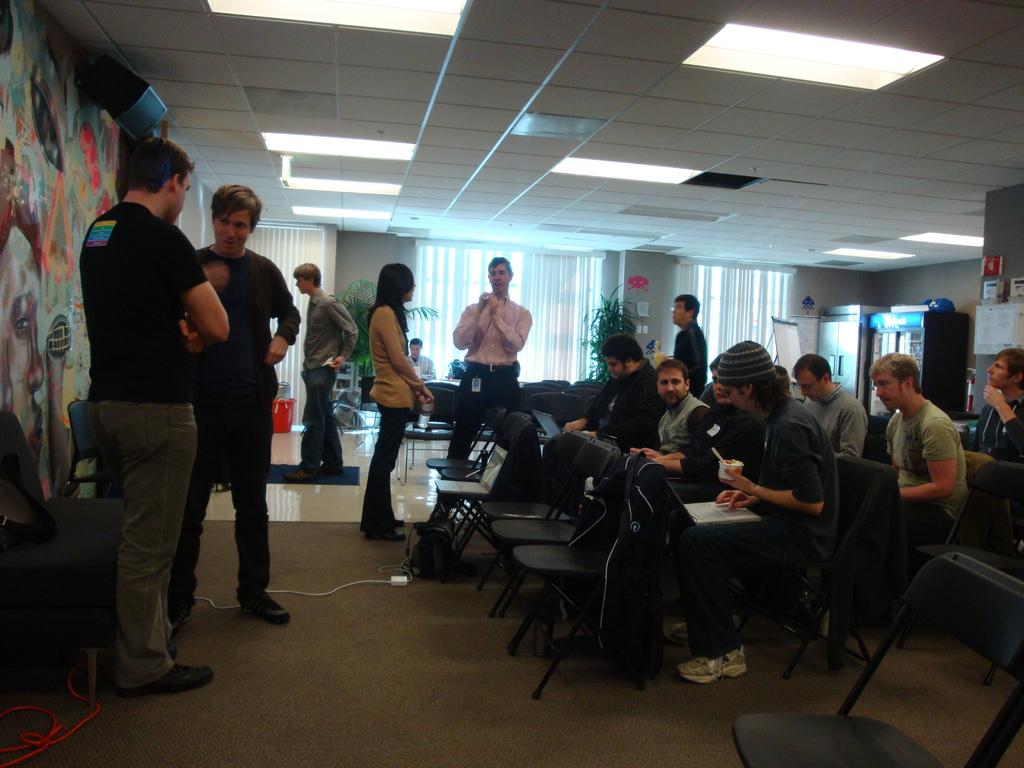What are the people in the image doing? There is a group of people sitting on chairs, and there are people standing on the roof. What can be seen in the background of the image? There are cupboards, a curtain, a water plant, and a window in the background. Are there any lights visible in the image? Yes, there are lights on the rooftop. What type of art can be seen on the observation deck in the image? There is no observation deck or art present in the image. 